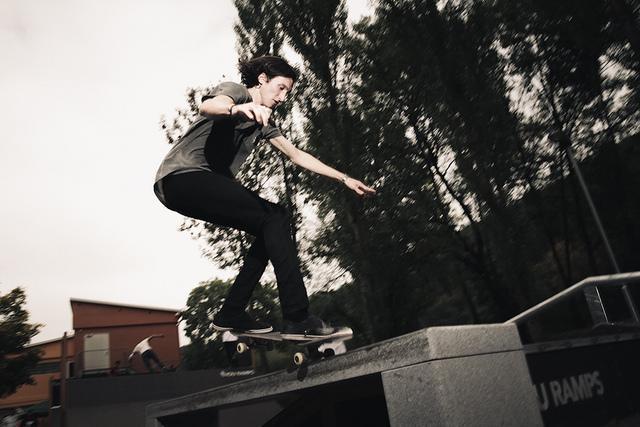How many people are shown in the photo?
Give a very brief answer. 2. How many skater's are shown?
Give a very brief answer. 1. How many feet are on the board?
Give a very brief answer. 2. 